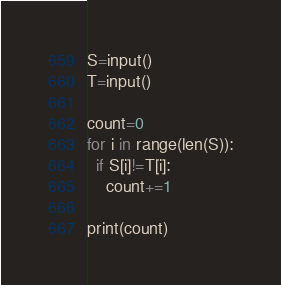<code> <loc_0><loc_0><loc_500><loc_500><_Python_>S=input()
T=input()

count=0
for i in range(len(S)):
  if S[i]!=T[i]:
    count+=1
    
print(count)

</code> 